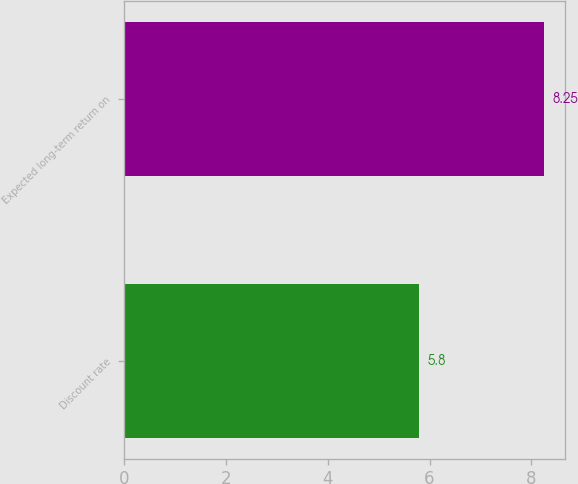<chart> <loc_0><loc_0><loc_500><loc_500><bar_chart><fcel>Discount rate<fcel>Expected long-term return on<nl><fcel>5.8<fcel>8.25<nl></chart> 